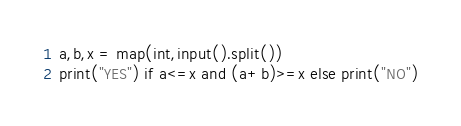<code> <loc_0><loc_0><loc_500><loc_500><_Python_>a,b,x = map(int,input().split())
print("YES") if a<=x and (a+b)>=x else print("NO")</code> 